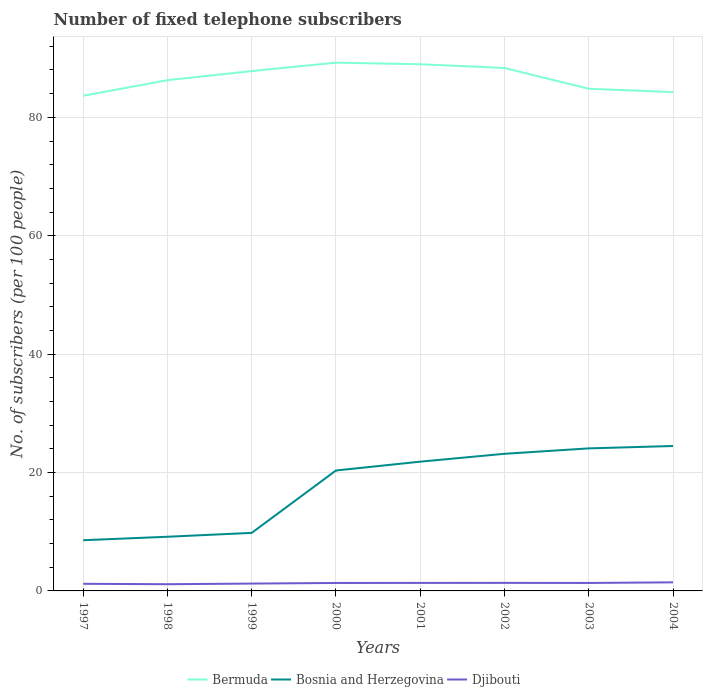Does the line corresponding to Bermuda intersect with the line corresponding to Bosnia and Herzegovina?
Offer a terse response. No. Across all years, what is the maximum number of fixed telephone subscribers in Bosnia and Herzegovina?
Keep it short and to the point. 8.57. In which year was the number of fixed telephone subscribers in Djibouti maximum?
Keep it short and to the point. 1998. What is the total number of fixed telephone subscribers in Bosnia and Herzegovina in the graph?
Ensure brevity in your answer.  -14.27. What is the difference between the highest and the second highest number of fixed telephone subscribers in Bermuda?
Make the answer very short. 5.59. What is the difference between the highest and the lowest number of fixed telephone subscribers in Djibouti?
Keep it short and to the point. 5. Is the number of fixed telephone subscribers in Djibouti strictly greater than the number of fixed telephone subscribers in Bermuda over the years?
Give a very brief answer. Yes. How many years are there in the graph?
Offer a terse response. 8. Does the graph contain any zero values?
Your answer should be compact. No. Does the graph contain grids?
Keep it short and to the point. Yes. How many legend labels are there?
Offer a terse response. 3. How are the legend labels stacked?
Your answer should be compact. Horizontal. What is the title of the graph?
Your answer should be very brief. Number of fixed telephone subscribers. What is the label or title of the X-axis?
Provide a short and direct response. Years. What is the label or title of the Y-axis?
Offer a terse response. No. of subscribers (per 100 people). What is the No. of subscribers (per 100 people) of Bermuda in 1997?
Ensure brevity in your answer.  83.64. What is the No. of subscribers (per 100 people) of Bosnia and Herzegovina in 1997?
Provide a short and direct response. 8.57. What is the No. of subscribers (per 100 people) in Djibouti in 1997?
Provide a succinct answer. 1.2. What is the No. of subscribers (per 100 people) in Bermuda in 1998?
Your answer should be very brief. 86.28. What is the No. of subscribers (per 100 people) in Bosnia and Herzegovina in 1998?
Provide a succinct answer. 9.15. What is the No. of subscribers (per 100 people) in Djibouti in 1998?
Offer a very short reply. 1.13. What is the No. of subscribers (per 100 people) in Bermuda in 1999?
Offer a very short reply. 87.81. What is the No. of subscribers (per 100 people) in Bosnia and Herzegovina in 1999?
Offer a very short reply. 9.81. What is the No. of subscribers (per 100 people) in Djibouti in 1999?
Provide a succinct answer. 1.24. What is the No. of subscribers (per 100 people) in Bermuda in 2000?
Provide a succinct answer. 89.24. What is the No. of subscribers (per 100 people) of Bosnia and Herzegovina in 2000?
Provide a succinct answer. 20.34. What is the No. of subscribers (per 100 people) in Djibouti in 2000?
Provide a succinct answer. 1.34. What is the No. of subscribers (per 100 people) in Bermuda in 2001?
Keep it short and to the point. 88.96. What is the No. of subscribers (per 100 people) of Bosnia and Herzegovina in 2001?
Provide a short and direct response. 21.83. What is the No. of subscribers (per 100 people) of Djibouti in 2001?
Ensure brevity in your answer.  1.35. What is the No. of subscribers (per 100 people) in Bermuda in 2002?
Your answer should be compact. 88.34. What is the No. of subscribers (per 100 people) in Bosnia and Herzegovina in 2002?
Make the answer very short. 23.16. What is the No. of subscribers (per 100 people) in Djibouti in 2002?
Your response must be concise. 1.36. What is the No. of subscribers (per 100 people) in Bermuda in 2003?
Give a very brief answer. 84.82. What is the No. of subscribers (per 100 people) in Bosnia and Herzegovina in 2003?
Make the answer very short. 24.08. What is the No. of subscribers (per 100 people) in Djibouti in 2003?
Keep it short and to the point. 1.35. What is the No. of subscribers (per 100 people) in Bermuda in 2004?
Your answer should be very brief. 84.26. What is the No. of subscribers (per 100 people) in Bosnia and Herzegovina in 2004?
Offer a very short reply. 24.48. What is the No. of subscribers (per 100 people) in Djibouti in 2004?
Make the answer very short. 1.45. Across all years, what is the maximum No. of subscribers (per 100 people) in Bermuda?
Your answer should be very brief. 89.24. Across all years, what is the maximum No. of subscribers (per 100 people) in Bosnia and Herzegovina?
Offer a terse response. 24.48. Across all years, what is the maximum No. of subscribers (per 100 people) of Djibouti?
Your response must be concise. 1.45. Across all years, what is the minimum No. of subscribers (per 100 people) in Bermuda?
Offer a terse response. 83.64. Across all years, what is the minimum No. of subscribers (per 100 people) in Bosnia and Herzegovina?
Ensure brevity in your answer.  8.57. Across all years, what is the minimum No. of subscribers (per 100 people) of Djibouti?
Your answer should be compact. 1.13. What is the total No. of subscribers (per 100 people) of Bermuda in the graph?
Give a very brief answer. 693.35. What is the total No. of subscribers (per 100 people) of Bosnia and Herzegovina in the graph?
Your answer should be compact. 141.42. What is the total No. of subscribers (per 100 people) in Djibouti in the graph?
Your answer should be very brief. 10.43. What is the difference between the No. of subscribers (per 100 people) of Bermuda in 1997 and that in 1998?
Give a very brief answer. -2.63. What is the difference between the No. of subscribers (per 100 people) of Bosnia and Herzegovina in 1997 and that in 1998?
Provide a short and direct response. -0.59. What is the difference between the No. of subscribers (per 100 people) of Djibouti in 1997 and that in 1998?
Offer a very short reply. 0.07. What is the difference between the No. of subscribers (per 100 people) of Bermuda in 1997 and that in 1999?
Your answer should be compact. -4.17. What is the difference between the No. of subscribers (per 100 people) in Bosnia and Herzegovina in 1997 and that in 1999?
Provide a succinct answer. -1.24. What is the difference between the No. of subscribers (per 100 people) in Djibouti in 1997 and that in 1999?
Give a very brief answer. -0.04. What is the difference between the No. of subscribers (per 100 people) in Bermuda in 1997 and that in 2000?
Offer a very short reply. -5.59. What is the difference between the No. of subscribers (per 100 people) in Bosnia and Herzegovina in 1997 and that in 2000?
Your answer should be compact. -11.78. What is the difference between the No. of subscribers (per 100 people) of Djibouti in 1997 and that in 2000?
Offer a very short reply. -0.14. What is the difference between the No. of subscribers (per 100 people) of Bermuda in 1997 and that in 2001?
Keep it short and to the point. -5.32. What is the difference between the No. of subscribers (per 100 people) in Bosnia and Herzegovina in 1997 and that in 2001?
Make the answer very short. -13.27. What is the difference between the No. of subscribers (per 100 people) in Djibouti in 1997 and that in 2001?
Your answer should be compact. -0.15. What is the difference between the No. of subscribers (per 100 people) in Bermuda in 1997 and that in 2002?
Offer a terse response. -4.69. What is the difference between the No. of subscribers (per 100 people) in Bosnia and Herzegovina in 1997 and that in 2002?
Offer a very short reply. -14.6. What is the difference between the No. of subscribers (per 100 people) of Djibouti in 1997 and that in 2002?
Offer a very short reply. -0.16. What is the difference between the No. of subscribers (per 100 people) of Bermuda in 1997 and that in 2003?
Offer a terse response. -1.18. What is the difference between the No. of subscribers (per 100 people) of Bosnia and Herzegovina in 1997 and that in 2003?
Provide a succinct answer. -15.51. What is the difference between the No. of subscribers (per 100 people) in Djibouti in 1997 and that in 2003?
Your answer should be very brief. -0.14. What is the difference between the No. of subscribers (per 100 people) in Bermuda in 1997 and that in 2004?
Your response must be concise. -0.61. What is the difference between the No. of subscribers (per 100 people) in Bosnia and Herzegovina in 1997 and that in 2004?
Offer a very short reply. -15.92. What is the difference between the No. of subscribers (per 100 people) of Djibouti in 1997 and that in 2004?
Your answer should be very brief. -0.25. What is the difference between the No. of subscribers (per 100 people) of Bermuda in 1998 and that in 1999?
Offer a terse response. -1.54. What is the difference between the No. of subscribers (per 100 people) in Bosnia and Herzegovina in 1998 and that in 1999?
Make the answer very short. -0.65. What is the difference between the No. of subscribers (per 100 people) in Djibouti in 1998 and that in 1999?
Give a very brief answer. -0.11. What is the difference between the No. of subscribers (per 100 people) in Bermuda in 1998 and that in 2000?
Make the answer very short. -2.96. What is the difference between the No. of subscribers (per 100 people) of Bosnia and Herzegovina in 1998 and that in 2000?
Provide a succinct answer. -11.19. What is the difference between the No. of subscribers (per 100 people) of Djibouti in 1998 and that in 2000?
Your answer should be very brief. -0.21. What is the difference between the No. of subscribers (per 100 people) in Bermuda in 1998 and that in 2001?
Your answer should be compact. -2.69. What is the difference between the No. of subscribers (per 100 people) of Bosnia and Herzegovina in 1998 and that in 2001?
Give a very brief answer. -12.68. What is the difference between the No. of subscribers (per 100 people) of Djibouti in 1998 and that in 2001?
Your answer should be very brief. -0.22. What is the difference between the No. of subscribers (per 100 people) in Bermuda in 1998 and that in 2002?
Make the answer very short. -2.06. What is the difference between the No. of subscribers (per 100 people) of Bosnia and Herzegovina in 1998 and that in 2002?
Make the answer very short. -14.01. What is the difference between the No. of subscribers (per 100 people) of Djibouti in 1998 and that in 2002?
Offer a terse response. -0.23. What is the difference between the No. of subscribers (per 100 people) of Bermuda in 1998 and that in 2003?
Ensure brevity in your answer.  1.45. What is the difference between the No. of subscribers (per 100 people) in Bosnia and Herzegovina in 1998 and that in 2003?
Your answer should be very brief. -14.93. What is the difference between the No. of subscribers (per 100 people) in Djibouti in 1998 and that in 2003?
Keep it short and to the point. -0.21. What is the difference between the No. of subscribers (per 100 people) of Bermuda in 1998 and that in 2004?
Provide a succinct answer. 2.02. What is the difference between the No. of subscribers (per 100 people) of Bosnia and Herzegovina in 1998 and that in 2004?
Keep it short and to the point. -15.33. What is the difference between the No. of subscribers (per 100 people) of Djibouti in 1998 and that in 2004?
Ensure brevity in your answer.  -0.32. What is the difference between the No. of subscribers (per 100 people) of Bermuda in 1999 and that in 2000?
Keep it short and to the point. -1.42. What is the difference between the No. of subscribers (per 100 people) in Bosnia and Herzegovina in 1999 and that in 2000?
Provide a short and direct response. -10.54. What is the difference between the No. of subscribers (per 100 people) of Djibouti in 1999 and that in 2000?
Keep it short and to the point. -0.1. What is the difference between the No. of subscribers (per 100 people) of Bermuda in 1999 and that in 2001?
Offer a terse response. -1.15. What is the difference between the No. of subscribers (per 100 people) of Bosnia and Herzegovina in 1999 and that in 2001?
Your answer should be very brief. -12.03. What is the difference between the No. of subscribers (per 100 people) in Djibouti in 1999 and that in 2001?
Make the answer very short. -0.11. What is the difference between the No. of subscribers (per 100 people) of Bermuda in 1999 and that in 2002?
Offer a very short reply. -0.53. What is the difference between the No. of subscribers (per 100 people) in Bosnia and Herzegovina in 1999 and that in 2002?
Ensure brevity in your answer.  -13.36. What is the difference between the No. of subscribers (per 100 people) in Djibouti in 1999 and that in 2002?
Your response must be concise. -0.12. What is the difference between the No. of subscribers (per 100 people) in Bermuda in 1999 and that in 2003?
Your answer should be compact. 2.99. What is the difference between the No. of subscribers (per 100 people) in Bosnia and Herzegovina in 1999 and that in 2003?
Your response must be concise. -14.27. What is the difference between the No. of subscribers (per 100 people) in Djibouti in 1999 and that in 2003?
Offer a terse response. -0.11. What is the difference between the No. of subscribers (per 100 people) of Bermuda in 1999 and that in 2004?
Your response must be concise. 3.55. What is the difference between the No. of subscribers (per 100 people) in Bosnia and Herzegovina in 1999 and that in 2004?
Make the answer very short. -14.68. What is the difference between the No. of subscribers (per 100 people) of Djibouti in 1999 and that in 2004?
Ensure brevity in your answer.  -0.21. What is the difference between the No. of subscribers (per 100 people) of Bermuda in 2000 and that in 2001?
Ensure brevity in your answer.  0.27. What is the difference between the No. of subscribers (per 100 people) in Bosnia and Herzegovina in 2000 and that in 2001?
Ensure brevity in your answer.  -1.49. What is the difference between the No. of subscribers (per 100 people) of Djibouti in 2000 and that in 2001?
Make the answer very short. -0.01. What is the difference between the No. of subscribers (per 100 people) in Bermuda in 2000 and that in 2002?
Your response must be concise. 0.9. What is the difference between the No. of subscribers (per 100 people) in Bosnia and Herzegovina in 2000 and that in 2002?
Ensure brevity in your answer.  -2.82. What is the difference between the No. of subscribers (per 100 people) of Djibouti in 2000 and that in 2002?
Your answer should be very brief. -0.02. What is the difference between the No. of subscribers (per 100 people) in Bermuda in 2000 and that in 2003?
Offer a terse response. 4.41. What is the difference between the No. of subscribers (per 100 people) in Bosnia and Herzegovina in 2000 and that in 2003?
Provide a succinct answer. -3.74. What is the difference between the No. of subscribers (per 100 people) of Djibouti in 2000 and that in 2003?
Make the answer very short. -0. What is the difference between the No. of subscribers (per 100 people) in Bermuda in 2000 and that in 2004?
Provide a short and direct response. 4.98. What is the difference between the No. of subscribers (per 100 people) of Bosnia and Herzegovina in 2000 and that in 2004?
Provide a short and direct response. -4.14. What is the difference between the No. of subscribers (per 100 people) in Djibouti in 2000 and that in 2004?
Offer a terse response. -0.11. What is the difference between the No. of subscribers (per 100 people) in Bermuda in 2001 and that in 2002?
Your response must be concise. 0.63. What is the difference between the No. of subscribers (per 100 people) of Bosnia and Herzegovina in 2001 and that in 2002?
Offer a terse response. -1.33. What is the difference between the No. of subscribers (per 100 people) in Djibouti in 2001 and that in 2002?
Give a very brief answer. -0.01. What is the difference between the No. of subscribers (per 100 people) of Bermuda in 2001 and that in 2003?
Provide a short and direct response. 4.14. What is the difference between the No. of subscribers (per 100 people) of Bosnia and Herzegovina in 2001 and that in 2003?
Ensure brevity in your answer.  -2.24. What is the difference between the No. of subscribers (per 100 people) of Djibouti in 2001 and that in 2003?
Ensure brevity in your answer.  0.01. What is the difference between the No. of subscribers (per 100 people) of Bermuda in 2001 and that in 2004?
Your answer should be very brief. 4.71. What is the difference between the No. of subscribers (per 100 people) of Bosnia and Herzegovina in 2001 and that in 2004?
Provide a short and direct response. -2.65. What is the difference between the No. of subscribers (per 100 people) of Djibouti in 2001 and that in 2004?
Your response must be concise. -0.1. What is the difference between the No. of subscribers (per 100 people) of Bermuda in 2002 and that in 2003?
Make the answer very short. 3.51. What is the difference between the No. of subscribers (per 100 people) of Bosnia and Herzegovina in 2002 and that in 2003?
Make the answer very short. -0.91. What is the difference between the No. of subscribers (per 100 people) in Djibouti in 2002 and that in 2003?
Ensure brevity in your answer.  0.01. What is the difference between the No. of subscribers (per 100 people) of Bermuda in 2002 and that in 2004?
Your answer should be compact. 4.08. What is the difference between the No. of subscribers (per 100 people) of Bosnia and Herzegovina in 2002 and that in 2004?
Provide a succinct answer. -1.32. What is the difference between the No. of subscribers (per 100 people) in Djibouti in 2002 and that in 2004?
Ensure brevity in your answer.  -0.09. What is the difference between the No. of subscribers (per 100 people) of Bermuda in 2003 and that in 2004?
Your answer should be very brief. 0.57. What is the difference between the No. of subscribers (per 100 people) in Bosnia and Herzegovina in 2003 and that in 2004?
Offer a terse response. -0.4. What is the difference between the No. of subscribers (per 100 people) in Djibouti in 2003 and that in 2004?
Your response must be concise. -0.1. What is the difference between the No. of subscribers (per 100 people) in Bermuda in 1997 and the No. of subscribers (per 100 people) in Bosnia and Herzegovina in 1998?
Ensure brevity in your answer.  74.49. What is the difference between the No. of subscribers (per 100 people) of Bermuda in 1997 and the No. of subscribers (per 100 people) of Djibouti in 1998?
Keep it short and to the point. 82.51. What is the difference between the No. of subscribers (per 100 people) of Bosnia and Herzegovina in 1997 and the No. of subscribers (per 100 people) of Djibouti in 1998?
Give a very brief answer. 7.43. What is the difference between the No. of subscribers (per 100 people) of Bermuda in 1997 and the No. of subscribers (per 100 people) of Bosnia and Herzegovina in 1999?
Provide a succinct answer. 73.84. What is the difference between the No. of subscribers (per 100 people) in Bermuda in 1997 and the No. of subscribers (per 100 people) in Djibouti in 1999?
Provide a succinct answer. 82.4. What is the difference between the No. of subscribers (per 100 people) of Bosnia and Herzegovina in 1997 and the No. of subscribers (per 100 people) of Djibouti in 1999?
Provide a short and direct response. 7.33. What is the difference between the No. of subscribers (per 100 people) of Bermuda in 1997 and the No. of subscribers (per 100 people) of Bosnia and Herzegovina in 2000?
Provide a succinct answer. 63.3. What is the difference between the No. of subscribers (per 100 people) in Bermuda in 1997 and the No. of subscribers (per 100 people) in Djibouti in 2000?
Give a very brief answer. 82.3. What is the difference between the No. of subscribers (per 100 people) of Bosnia and Herzegovina in 1997 and the No. of subscribers (per 100 people) of Djibouti in 2000?
Your answer should be very brief. 7.22. What is the difference between the No. of subscribers (per 100 people) in Bermuda in 1997 and the No. of subscribers (per 100 people) in Bosnia and Herzegovina in 2001?
Provide a short and direct response. 61.81. What is the difference between the No. of subscribers (per 100 people) of Bermuda in 1997 and the No. of subscribers (per 100 people) of Djibouti in 2001?
Your response must be concise. 82.29. What is the difference between the No. of subscribers (per 100 people) in Bosnia and Herzegovina in 1997 and the No. of subscribers (per 100 people) in Djibouti in 2001?
Your answer should be very brief. 7.21. What is the difference between the No. of subscribers (per 100 people) of Bermuda in 1997 and the No. of subscribers (per 100 people) of Bosnia and Herzegovina in 2002?
Keep it short and to the point. 60.48. What is the difference between the No. of subscribers (per 100 people) in Bermuda in 1997 and the No. of subscribers (per 100 people) in Djibouti in 2002?
Your response must be concise. 82.28. What is the difference between the No. of subscribers (per 100 people) of Bosnia and Herzegovina in 1997 and the No. of subscribers (per 100 people) of Djibouti in 2002?
Make the answer very short. 7.21. What is the difference between the No. of subscribers (per 100 people) of Bermuda in 1997 and the No. of subscribers (per 100 people) of Bosnia and Herzegovina in 2003?
Keep it short and to the point. 59.57. What is the difference between the No. of subscribers (per 100 people) of Bermuda in 1997 and the No. of subscribers (per 100 people) of Djibouti in 2003?
Provide a succinct answer. 82.3. What is the difference between the No. of subscribers (per 100 people) in Bosnia and Herzegovina in 1997 and the No. of subscribers (per 100 people) in Djibouti in 2003?
Your answer should be very brief. 7.22. What is the difference between the No. of subscribers (per 100 people) in Bermuda in 1997 and the No. of subscribers (per 100 people) in Bosnia and Herzegovina in 2004?
Your answer should be compact. 59.16. What is the difference between the No. of subscribers (per 100 people) in Bermuda in 1997 and the No. of subscribers (per 100 people) in Djibouti in 2004?
Offer a very short reply. 82.19. What is the difference between the No. of subscribers (per 100 people) of Bosnia and Herzegovina in 1997 and the No. of subscribers (per 100 people) of Djibouti in 2004?
Your response must be concise. 7.12. What is the difference between the No. of subscribers (per 100 people) of Bermuda in 1998 and the No. of subscribers (per 100 people) of Bosnia and Herzegovina in 1999?
Your answer should be compact. 76.47. What is the difference between the No. of subscribers (per 100 people) in Bermuda in 1998 and the No. of subscribers (per 100 people) in Djibouti in 1999?
Make the answer very short. 85.04. What is the difference between the No. of subscribers (per 100 people) of Bosnia and Herzegovina in 1998 and the No. of subscribers (per 100 people) of Djibouti in 1999?
Keep it short and to the point. 7.91. What is the difference between the No. of subscribers (per 100 people) in Bermuda in 1998 and the No. of subscribers (per 100 people) in Bosnia and Herzegovina in 2000?
Make the answer very short. 65.93. What is the difference between the No. of subscribers (per 100 people) in Bermuda in 1998 and the No. of subscribers (per 100 people) in Djibouti in 2000?
Provide a succinct answer. 84.93. What is the difference between the No. of subscribers (per 100 people) of Bosnia and Herzegovina in 1998 and the No. of subscribers (per 100 people) of Djibouti in 2000?
Your answer should be compact. 7.81. What is the difference between the No. of subscribers (per 100 people) in Bermuda in 1998 and the No. of subscribers (per 100 people) in Bosnia and Herzegovina in 2001?
Provide a short and direct response. 64.44. What is the difference between the No. of subscribers (per 100 people) in Bermuda in 1998 and the No. of subscribers (per 100 people) in Djibouti in 2001?
Provide a succinct answer. 84.92. What is the difference between the No. of subscribers (per 100 people) in Bosnia and Herzegovina in 1998 and the No. of subscribers (per 100 people) in Djibouti in 2001?
Offer a very short reply. 7.8. What is the difference between the No. of subscribers (per 100 people) of Bermuda in 1998 and the No. of subscribers (per 100 people) of Bosnia and Herzegovina in 2002?
Provide a succinct answer. 63.11. What is the difference between the No. of subscribers (per 100 people) in Bermuda in 1998 and the No. of subscribers (per 100 people) in Djibouti in 2002?
Ensure brevity in your answer.  84.92. What is the difference between the No. of subscribers (per 100 people) of Bosnia and Herzegovina in 1998 and the No. of subscribers (per 100 people) of Djibouti in 2002?
Provide a short and direct response. 7.79. What is the difference between the No. of subscribers (per 100 people) of Bermuda in 1998 and the No. of subscribers (per 100 people) of Bosnia and Herzegovina in 2003?
Your answer should be very brief. 62.2. What is the difference between the No. of subscribers (per 100 people) in Bermuda in 1998 and the No. of subscribers (per 100 people) in Djibouti in 2003?
Your response must be concise. 84.93. What is the difference between the No. of subscribers (per 100 people) of Bosnia and Herzegovina in 1998 and the No. of subscribers (per 100 people) of Djibouti in 2003?
Your answer should be very brief. 7.8. What is the difference between the No. of subscribers (per 100 people) of Bermuda in 1998 and the No. of subscribers (per 100 people) of Bosnia and Herzegovina in 2004?
Your answer should be compact. 61.8. What is the difference between the No. of subscribers (per 100 people) in Bermuda in 1998 and the No. of subscribers (per 100 people) in Djibouti in 2004?
Give a very brief answer. 84.83. What is the difference between the No. of subscribers (per 100 people) in Bosnia and Herzegovina in 1998 and the No. of subscribers (per 100 people) in Djibouti in 2004?
Provide a short and direct response. 7.7. What is the difference between the No. of subscribers (per 100 people) in Bermuda in 1999 and the No. of subscribers (per 100 people) in Bosnia and Herzegovina in 2000?
Keep it short and to the point. 67.47. What is the difference between the No. of subscribers (per 100 people) of Bermuda in 1999 and the No. of subscribers (per 100 people) of Djibouti in 2000?
Offer a terse response. 86.47. What is the difference between the No. of subscribers (per 100 people) in Bosnia and Herzegovina in 1999 and the No. of subscribers (per 100 people) in Djibouti in 2000?
Your response must be concise. 8.46. What is the difference between the No. of subscribers (per 100 people) of Bermuda in 1999 and the No. of subscribers (per 100 people) of Bosnia and Herzegovina in 2001?
Your answer should be very brief. 65.98. What is the difference between the No. of subscribers (per 100 people) in Bermuda in 1999 and the No. of subscribers (per 100 people) in Djibouti in 2001?
Provide a short and direct response. 86.46. What is the difference between the No. of subscribers (per 100 people) in Bosnia and Herzegovina in 1999 and the No. of subscribers (per 100 people) in Djibouti in 2001?
Your answer should be compact. 8.45. What is the difference between the No. of subscribers (per 100 people) in Bermuda in 1999 and the No. of subscribers (per 100 people) in Bosnia and Herzegovina in 2002?
Provide a succinct answer. 64.65. What is the difference between the No. of subscribers (per 100 people) of Bermuda in 1999 and the No. of subscribers (per 100 people) of Djibouti in 2002?
Offer a very short reply. 86.45. What is the difference between the No. of subscribers (per 100 people) in Bosnia and Herzegovina in 1999 and the No. of subscribers (per 100 people) in Djibouti in 2002?
Your answer should be compact. 8.45. What is the difference between the No. of subscribers (per 100 people) of Bermuda in 1999 and the No. of subscribers (per 100 people) of Bosnia and Herzegovina in 2003?
Provide a short and direct response. 63.73. What is the difference between the No. of subscribers (per 100 people) of Bermuda in 1999 and the No. of subscribers (per 100 people) of Djibouti in 2003?
Give a very brief answer. 86.47. What is the difference between the No. of subscribers (per 100 people) in Bosnia and Herzegovina in 1999 and the No. of subscribers (per 100 people) in Djibouti in 2003?
Make the answer very short. 8.46. What is the difference between the No. of subscribers (per 100 people) of Bermuda in 1999 and the No. of subscribers (per 100 people) of Bosnia and Herzegovina in 2004?
Your response must be concise. 63.33. What is the difference between the No. of subscribers (per 100 people) of Bermuda in 1999 and the No. of subscribers (per 100 people) of Djibouti in 2004?
Give a very brief answer. 86.36. What is the difference between the No. of subscribers (per 100 people) of Bosnia and Herzegovina in 1999 and the No. of subscribers (per 100 people) of Djibouti in 2004?
Keep it short and to the point. 8.36. What is the difference between the No. of subscribers (per 100 people) of Bermuda in 2000 and the No. of subscribers (per 100 people) of Bosnia and Herzegovina in 2001?
Your response must be concise. 67.4. What is the difference between the No. of subscribers (per 100 people) in Bermuda in 2000 and the No. of subscribers (per 100 people) in Djibouti in 2001?
Your answer should be very brief. 87.88. What is the difference between the No. of subscribers (per 100 people) in Bosnia and Herzegovina in 2000 and the No. of subscribers (per 100 people) in Djibouti in 2001?
Offer a very short reply. 18.99. What is the difference between the No. of subscribers (per 100 people) of Bermuda in 2000 and the No. of subscribers (per 100 people) of Bosnia and Herzegovina in 2002?
Keep it short and to the point. 66.07. What is the difference between the No. of subscribers (per 100 people) in Bermuda in 2000 and the No. of subscribers (per 100 people) in Djibouti in 2002?
Ensure brevity in your answer.  87.88. What is the difference between the No. of subscribers (per 100 people) in Bosnia and Herzegovina in 2000 and the No. of subscribers (per 100 people) in Djibouti in 2002?
Offer a very short reply. 18.98. What is the difference between the No. of subscribers (per 100 people) of Bermuda in 2000 and the No. of subscribers (per 100 people) of Bosnia and Herzegovina in 2003?
Offer a very short reply. 65.16. What is the difference between the No. of subscribers (per 100 people) in Bermuda in 2000 and the No. of subscribers (per 100 people) in Djibouti in 2003?
Your answer should be very brief. 87.89. What is the difference between the No. of subscribers (per 100 people) of Bosnia and Herzegovina in 2000 and the No. of subscribers (per 100 people) of Djibouti in 2003?
Your answer should be compact. 19. What is the difference between the No. of subscribers (per 100 people) in Bermuda in 2000 and the No. of subscribers (per 100 people) in Bosnia and Herzegovina in 2004?
Offer a very short reply. 64.75. What is the difference between the No. of subscribers (per 100 people) of Bermuda in 2000 and the No. of subscribers (per 100 people) of Djibouti in 2004?
Offer a very short reply. 87.79. What is the difference between the No. of subscribers (per 100 people) in Bosnia and Herzegovina in 2000 and the No. of subscribers (per 100 people) in Djibouti in 2004?
Provide a short and direct response. 18.89. What is the difference between the No. of subscribers (per 100 people) of Bermuda in 2001 and the No. of subscribers (per 100 people) of Bosnia and Herzegovina in 2002?
Offer a terse response. 65.8. What is the difference between the No. of subscribers (per 100 people) of Bermuda in 2001 and the No. of subscribers (per 100 people) of Djibouti in 2002?
Make the answer very short. 87.6. What is the difference between the No. of subscribers (per 100 people) of Bosnia and Herzegovina in 2001 and the No. of subscribers (per 100 people) of Djibouti in 2002?
Your answer should be compact. 20.47. What is the difference between the No. of subscribers (per 100 people) of Bermuda in 2001 and the No. of subscribers (per 100 people) of Bosnia and Herzegovina in 2003?
Make the answer very short. 64.89. What is the difference between the No. of subscribers (per 100 people) of Bermuda in 2001 and the No. of subscribers (per 100 people) of Djibouti in 2003?
Make the answer very short. 87.62. What is the difference between the No. of subscribers (per 100 people) in Bosnia and Herzegovina in 2001 and the No. of subscribers (per 100 people) in Djibouti in 2003?
Keep it short and to the point. 20.49. What is the difference between the No. of subscribers (per 100 people) of Bermuda in 2001 and the No. of subscribers (per 100 people) of Bosnia and Herzegovina in 2004?
Offer a very short reply. 64.48. What is the difference between the No. of subscribers (per 100 people) of Bermuda in 2001 and the No. of subscribers (per 100 people) of Djibouti in 2004?
Offer a very short reply. 87.51. What is the difference between the No. of subscribers (per 100 people) of Bosnia and Herzegovina in 2001 and the No. of subscribers (per 100 people) of Djibouti in 2004?
Ensure brevity in your answer.  20.38. What is the difference between the No. of subscribers (per 100 people) in Bermuda in 2002 and the No. of subscribers (per 100 people) in Bosnia and Herzegovina in 2003?
Your answer should be compact. 64.26. What is the difference between the No. of subscribers (per 100 people) of Bermuda in 2002 and the No. of subscribers (per 100 people) of Djibouti in 2003?
Make the answer very short. 86.99. What is the difference between the No. of subscribers (per 100 people) of Bosnia and Herzegovina in 2002 and the No. of subscribers (per 100 people) of Djibouti in 2003?
Your response must be concise. 21.82. What is the difference between the No. of subscribers (per 100 people) in Bermuda in 2002 and the No. of subscribers (per 100 people) in Bosnia and Herzegovina in 2004?
Offer a very short reply. 63.86. What is the difference between the No. of subscribers (per 100 people) in Bermuda in 2002 and the No. of subscribers (per 100 people) in Djibouti in 2004?
Offer a very short reply. 86.89. What is the difference between the No. of subscribers (per 100 people) in Bosnia and Herzegovina in 2002 and the No. of subscribers (per 100 people) in Djibouti in 2004?
Your response must be concise. 21.71. What is the difference between the No. of subscribers (per 100 people) in Bermuda in 2003 and the No. of subscribers (per 100 people) in Bosnia and Herzegovina in 2004?
Make the answer very short. 60.34. What is the difference between the No. of subscribers (per 100 people) of Bermuda in 2003 and the No. of subscribers (per 100 people) of Djibouti in 2004?
Your answer should be compact. 83.37. What is the difference between the No. of subscribers (per 100 people) in Bosnia and Herzegovina in 2003 and the No. of subscribers (per 100 people) in Djibouti in 2004?
Give a very brief answer. 22.63. What is the average No. of subscribers (per 100 people) of Bermuda per year?
Make the answer very short. 86.67. What is the average No. of subscribers (per 100 people) in Bosnia and Herzegovina per year?
Make the answer very short. 17.68. What is the average No. of subscribers (per 100 people) in Djibouti per year?
Your answer should be very brief. 1.3. In the year 1997, what is the difference between the No. of subscribers (per 100 people) in Bermuda and No. of subscribers (per 100 people) in Bosnia and Herzegovina?
Make the answer very short. 75.08. In the year 1997, what is the difference between the No. of subscribers (per 100 people) in Bermuda and No. of subscribers (per 100 people) in Djibouti?
Give a very brief answer. 82.44. In the year 1997, what is the difference between the No. of subscribers (per 100 people) of Bosnia and Herzegovina and No. of subscribers (per 100 people) of Djibouti?
Provide a succinct answer. 7.36. In the year 1998, what is the difference between the No. of subscribers (per 100 people) in Bermuda and No. of subscribers (per 100 people) in Bosnia and Herzegovina?
Your answer should be very brief. 77.13. In the year 1998, what is the difference between the No. of subscribers (per 100 people) of Bermuda and No. of subscribers (per 100 people) of Djibouti?
Provide a succinct answer. 85.14. In the year 1998, what is the difference between the No. of subscribers (per 100 people) of Bosnia and Herzegovina and No. of subscribers (per 100 people) of Djibouti?
Your answer should be very brief. 8.02. In the year 1999, what is the difference between the No. of subscribers (per 100 people) of Bermuda and No. of subscribers (per 100 people) of Bosnia and Herzegovina?
Ensure brevity in your answer.  78.01. In the year 1999, what is the difference between the No. of subscribers (per 100 people) of Bermuda and No. of subscribers (per 100 people) of Djibouti?
Keep it short and to the point. 86.57. In the year 1999, what is the difference between the No. of subscribers (per 100 people) of Bosnia and Herzegovina and No. of subscribers (per 100 people) of Djibouti?
Offer a terse response. 8.57. In the year 2000, what is the difference between the No. of subscribers (per 100 people) in Bermuda and No. of subscribers (per 100 people) in Bosnia and Herzegovina?
Provide a short and direct response. 68.89. In the year 2000, what is the difference between the No. of subscribers (per 100 people) of Bermuda and No. of subscribers (per 100 people) of Djibouti?
Ensure brevity in your answer.  87.89. In the year 2000, what is the difference between the No. of subscribers (per 100 people) in Bosnia and Herzegovina and No. of subscribers (per 100 people) in Djibouti?
Your response must be concise. 19. In the year 2001, what is the difference between the No. of subscribers (per 100 people) in Bermuda and No. of subscribers (per 100 people) in Bosnia and Herzegovina?
Provide a short and direct response. 67.13. In the year 2001, what is the difference between the No. of subscribers (per 100 people) in Bermuda and No. of subscribers (per 100 people) in Djibouti?
Your answer should be compact. 87.61. In the year 2001, what is the difference between the No. of subscribers (per 100 people) in Bosnia and Herzegovina and No. of subscribers (per 100 people) in Djibouti?
Ensure brevity in your answer.  20.48. In the year 2002, what is the difference between the No. of subscribers (per 100 people) in Bermuda and No. of subscribers (per 100 people) in Bosnia and Herzegovina?
Your answer should be very brief. 65.17. In the year 2002, what is the difference between the No. of subscribers (per 100 people) in Bermuda and No. of subscribers (per 100 people) in Djibouti?
Your answer should be very brief. 86.98. In the year 2002, what is the difference between the No. of subscribers (per 100 people) in Bosnia and Herzegovina and No. of subscribers (per 100 people) in Djibouti?
Your answer should be compact. 21.8. In the year 2003, what is the difference between the No. of subscribers (per 100 people) of Bermuda and No. of subscribers (per 100 people) of Bosnia and Herzegovina?
Your answer should be compact. 60.75. In the year 2003, what is the difference between the No. of subscribers (per 100 people) in Bermuda and No. of subscribers (per 100 people) in Djibouti?
Keep it short and to the point. 83.48. In the year 2003, what is the difference between the No. of subscribers (per 100 people) of Bosnia and Herzegovina and No. of subscribers (per 100 people) of Djibouti?
Make the answer very short. 22.73. In the year 2004, what is the difference between the No. of subscribers (per 100 people) in Bermuda and No. of subscribers (per 100 people) in Bosnia and Herzegovina?
Offer a terse response. 59.78. In the year 2004, what is the difference between the No. of subscribers (per 100 people) in Bermuda and No. of subscribers (per 100 people) in Djibouti?
Make the answer very short. 82.81. In the year 2004, what is the difference between the No. of subscribers (per 100 people) in Bosnia and Herzegovina and No. of subscribers (per 100 people) in Djibouti?
Your answer should be very brief. 23.03. What is the ratio of the No. of subscribers (per 100 people) of Bermuda in 1997 to that in 1998?
Ensure brevity in your answer.  0.97. What is the ratio of the No. of subscribers (per 100 people) in Bosnia and Herzegovina in 1997 to that in 1998?
Make the answer very short. 0.94. What is the ratio of the No. of subscribers (per 100 people) in Bermuda in 1997 to that in 1999?
Provide a short and direct response. 0.95. What is the ratio of the No. of subscribers (per 100 people) of Bosnia and Herzegovina in 1997 to that in 1999?
Your answer should be very brief. 0.87. What is the ratio of the No. of subscribers (per 100 people) in Djibouti in 1997 to that in 1999?
Offer a very short reply. 0.97. What is the ratio of the No. of subscribers (per 100 people) in Bermuda in 1997 to that in 2000?
Provide a short and direct response. 0.94. What is the ratio of the No. of subscribers (per 100 people) of Bosnia and Herzegovina in 1997 to that in 2000?
Make the answer very short. 0.42. What is the ratio of the No. of subscribers (per 100 people) in Djibouti in 1997 to that in 2000?
Your response must be concise. 0.9. What is the ratio of the No. of subscribers (per 100 people) in Bermuda in 1997 to that in 2001?
Keep it short and to the point. 0.94. What is the ratio of the No. of subscribers (per 100 people) in Bosnia and Herzegovina in 1997 to that in 2001?
Offer a very short reply. 0.39. What is the ratio of the No. of subscribers (per 100 people) in Djibouti in 1997 to that in 2001?
Your response must be concise. 0.89. What is the ratio of the No. of subscribers (per 100 people) in Bermuda in 1997 to that in 2002?
Provide a short and direct response. 0.95. What is the ratio of the No. of subscribers (per 100 people) in Bosnia and Herzegovina in 1997 to that in 2002?
Your answer should be very brief. 0.37. What is the ratio of the No. of subscribers (per 100 people) of Djibouti in 1997 to that in 2002?
Give a very brief answer. 0.89. What is the ratio of the No. of subscribers (per 100 people) in Bermuda in 1997 to that in 2003?
Give a very brief answer. 0.99. What is the ratio of the No. of subscribers (per 100 people) of Bosnia and Herzegovina in 1997 to that in 2003?
Offer a very short reply. 0.36. What is the ratio of the No. of subscribers (per 100 people) of Djibouti in 1997 to that in 2003?
Your answer should be compact. 0.89. What is the ratio of the No. of subscribers (per 100 people) of Bermuda in 1997 to that in 2004?
Your answer should be compact. 0.99. What is the ratio of the No. of subscribers (per 100 people) in Bosnia and Herzegovina in 1997 to that in 2004?
Keep it short and to the point. 0.35. What is the ratio of the No. of subscribers (per 100 people) of Djibouti in 1997 to that in 2004?
Ensure brevity in your answer.  0.83. What is the ratio of the No. of subscribers (per 100 people) in Bermuda in 1998 to that in 1999?
Your response must be concise. 0.98. What is the ratio of the No. of subscribers (per 100 people) of Bosnia and Herzegovina in 1998 to that in 1999?
Give a very brief answer. 0.93. What is the ratio of the No. of subscribers (per 100 people) in Djibouti in 1998 to that in 1999?
Your answer should be very brief. 0.91. What is the ratio of the No. of subscribers (per 100 people) of Bermuda in 1998 to that in 2000?
Your response must be concise. 0.97. What is the ratio of the No. of subscribers (per 100 people) of Bosnia and Herzegovina in 1998 to that in 2000?
Provide a succinct answer. 0.45. What is the ratio of the No. of subscribers (per 100 people) of Djibouti in 1998 to that in 2000?
Make the answer very short. 0.84. What is the ratio of the No. of subscribers (per 100 people) in Bermuda in 1998 to that in 2001?
Your answer should be compact. 0.97. What is the ratio of the No. of subscribers (per 100 people) of Bosnia and Herzegovina in 1998 to that in 2001?
Offer a terse response. 0.42. What is the ratio of the No. of subscribers (per 100 people) of Djibouti in 1998 to that in 2001?
Give a very brief answer. 0.84. What is the ratio of the No. of subscribers (per 100 people) of Bermuda in 1998 to that in 2002?
Make the answer very short. 0.98. What is the ratio of the No. of subscribers (per 100 people) of Bosnia and Herzegovina in 1998 to that in 2002?
Give a very brief answer. 0.4. What is the ratio of the No. of subscribers (per 100 people) in Djibouti in 1998 to that in 2002?
Provide a short and direct response. 0.83. What is the ratio of the No. of subscribers (per 100 people) of Bermuda in 1998 to that in 2003?
Your response must be concise. 1.02. What is the ratio of the No. of subscribers (per 100 people) of Bosnia and Herzegovina in 1998 to that in 2003?
Your response must be concise. 0.38. What is the ratio of the No. of subscribers (per 100 people) in Djibouti in 1998 to that in 2003?
Provide a succinct answer. 0.84. What is the ratio of the No. of subscribers (per 100 people) in Bermuda in 1998 to that in 2004?
Ensure brevity in your answer.  1.02. What is the ratio of the No. of subscribers (per 100 people) of Bosnia and Herzegovina in 1998 to that in 2004?
Provide a short and direct response. 0.37. What is the ratio of the No. of subscribers (per 100 people) of Djibouti in 1998 to that in 2004?
Make the answer very short. 0.78. What is the ratio of the No. of subscribers (per 100 people) of Bermuda in 1999 to that in 2000?
Provide a short and direct response. 0.98. What is the ratio of the No. of subscribers (per 100 people) of Bosnia and Herzegovina in 1999 to that in 2000?
Keep it short and to the point. 0.48. What is the ratio of the No. of subscribers (per 100 people) of Djibouti in 1999 to that in 2000?
Provide a succinct answer. 0.92. What is the ratio of the No. of subscribers (per 100 people) of Bermuda in 1999 to that in 2001?
Keep it short and to the point. 0.99. What is the ratio of the No. of subscribers (per 100 people) of Bosnia and Herzegovina in 1999 to that in 2001?
Offer a very short reply. 0.45. What is the ratio of the No. of subscribers (per 100 people) in Bosnia and Herzegovina in 1999 to that in 2002?
Your answer should be compact. 0.42. What is the ratio of the No. of subscribers (per 100 people) in Djibouti in 1999 to that in 2002?
Keep it short and to the point. 0.91. What is the ratio of the No. of subscribers (per 100 people) in Bermuda in 1999 to that in 2003?
Make the answer very short. 1.04. What is the ratio of the No. of subscribers (per 100 people) in Bosnia and Herzegovina in 1999 to that in 2003?
Give a very brief answer. 0.41. What is the ratio of the No. of subscribers (per 100 people) of Djibouti in 1999 to that in 2003?
Your answer should be very brief. 0.92. What is the ratio of the No. of subscribers (per 100 people) of Bermuda in 1999 to that in 2004?
Provide a short and direct response. 1.04. What is the ratio of the No. of subscribers (per 100 people) of Bosnia and Herzegovina in 1999 to that in 2004?
Provide a succinct answer. 0.4. What is the ratio of the No. of subscribers (per 100 people) in Djibouti in 1999 to that in 2004?
Your response must be concise. 0.86. What is the ratio of the No. of subscribers (per 100 people) of Bosnia and Herzegovina in 2000 to that in 2001?
Give a very brief answer. 0.93. What is the ratio of the No. of subscribers (per 100 people) in Bermuda in 2000 to that in 2002?
Provide a short and direct response. 1.01. What is the ratio of the No. of subscribers (per 100 people) of Bosnia and Herzegovina in 2000 to that in 2002?
Offer a very short reply. 0.88. What is the ratio of the No. of subscribers (per 100 people) in Bermuda in 2000 to that in 2003?
Your response must be concise. 1.05. What is the ratio of the No. of subscribers (per 100 people) in Bosnia and Herzegovina in 2000 to that in 2003?
Provide a short and direct response. 0.84. What is the ratio of the No. of subscribers (per 100 people) of Bermuda in 2000 to that in 2004?
Your response must be concise. 1.06. What is the ratio of the No. of subscribers (per 100 people) in Bosnia and Herzegovina in 2000 to that in 2004?
Offer a very short reply. 0.83. What is the ratio of the No. of subscribers (per 100 people) in Djibouti in 2000 to that in 2004?
Your answer should be compact. 0.93. What is the ratio of the No. of subscribers (per 100 people) of Bermuda in 2001 to that in 2002?
Your answer should be compact. 1.01. What is the ratio of the No. of subscribers (per 100 people) in Bosnia and Herzegovina in 2001 to that in 2002?
Your answer should be very brief. 0.94. What is the ratio of the No. of subscribers (per 100 people) in Djibouti in 2001 to that in 2002?
Your answer should be compact. 1. What is the ratio of the No. of subscribers (per 100 people) of Bermuda in 2001 to that in 2003?
Provide a short and direct response. 1.05. What is the ratio of the No. of subscribers (per 100 people) of Bosnia and Herzegovina in 2001 to that in 2003?
Keep it short and to the point. 0.91. What is the ratio of the No. of subscribers (per 100 people) of Bermuda in 2001 to that in 2004?
Your answer should be very brief. 1.06. What is the ratio of the No. of subscribers (per 100 people) of Bosnia and Herzegovina in 2001 to that in 2004?
Give a very brief answer. 0.89. What is the ratio of the No. of subscribers (per 100 people) of Djibouti in 2001 to that in 2004?
Offer a very short reply. 0.93. What is the ratio of the No. of subscribers (per 100 people) of Bermuda in 2002 to that in 2003?
Your answer should be very brief. 1.04. What is the ratio of the No. of subscribers (per 100 people) of Bosnia and Herzegovina in 2002 to that in 2003?
Offer a terse response. 0.96. What is the ratio of the No. of subscribers (per 100 people) of Djibouti in 2002 to that in 2003?
Ensure brevity in your answer.  1.01. What is the ratio of the No. of subscribers (per 100 people) of Bermuda in 2002 to that in 2004?
Keep it short and to the point. 1.05. What is the ratio of the No. of subscribers (per 100 people) of Bosnia and Herzegovina in 2002 to that in 2004?
Your response must be concise. 0.95. What is the ratio of the No. of subscribers (per 100 people) of Djibouti in 2002 to that in 2004?
Make the answer very short. 0.94. What is the ratio of the No. of subscribers (per 100 people) of Bosnia and Herzegovina in 2003 to that in 2004?
Offer a terse response. 0.98. What is the ratio of the No. of subscribers (per 100 people) of Djibouti in 2003 to that in 2004?
Provide a short and direct response. 0.93. What is the difference between the highest and the second highest No. of subscribers (per 100 people) in Bermuda?
Make the answer very short. 0.27. What is the difference between the highest and the second highest No. of subscribers (per 100 people) in Bosnia and Herzegovina?
Give a very brief answer. 0.4. What is the difference between the highest and the second highest No. of subscribers (per 100 people) in Djibouti?
Provide a succinct answer. 0.09. What is the difference between the highest and the lowest No. of subscribers (per 100 people) in Bermuda?
Provide a short and direct response. 5.59. What is the difference between the highest and the lowest No. of subscribers (per 100 people) of Bosnia and Herzegovina?
Provide a succinct answer. 15.92. What is the difference between the highest and the lowest No. of subscribers (per 100 people) in Djibouti?
Keep it short and to the point. 0.32. 